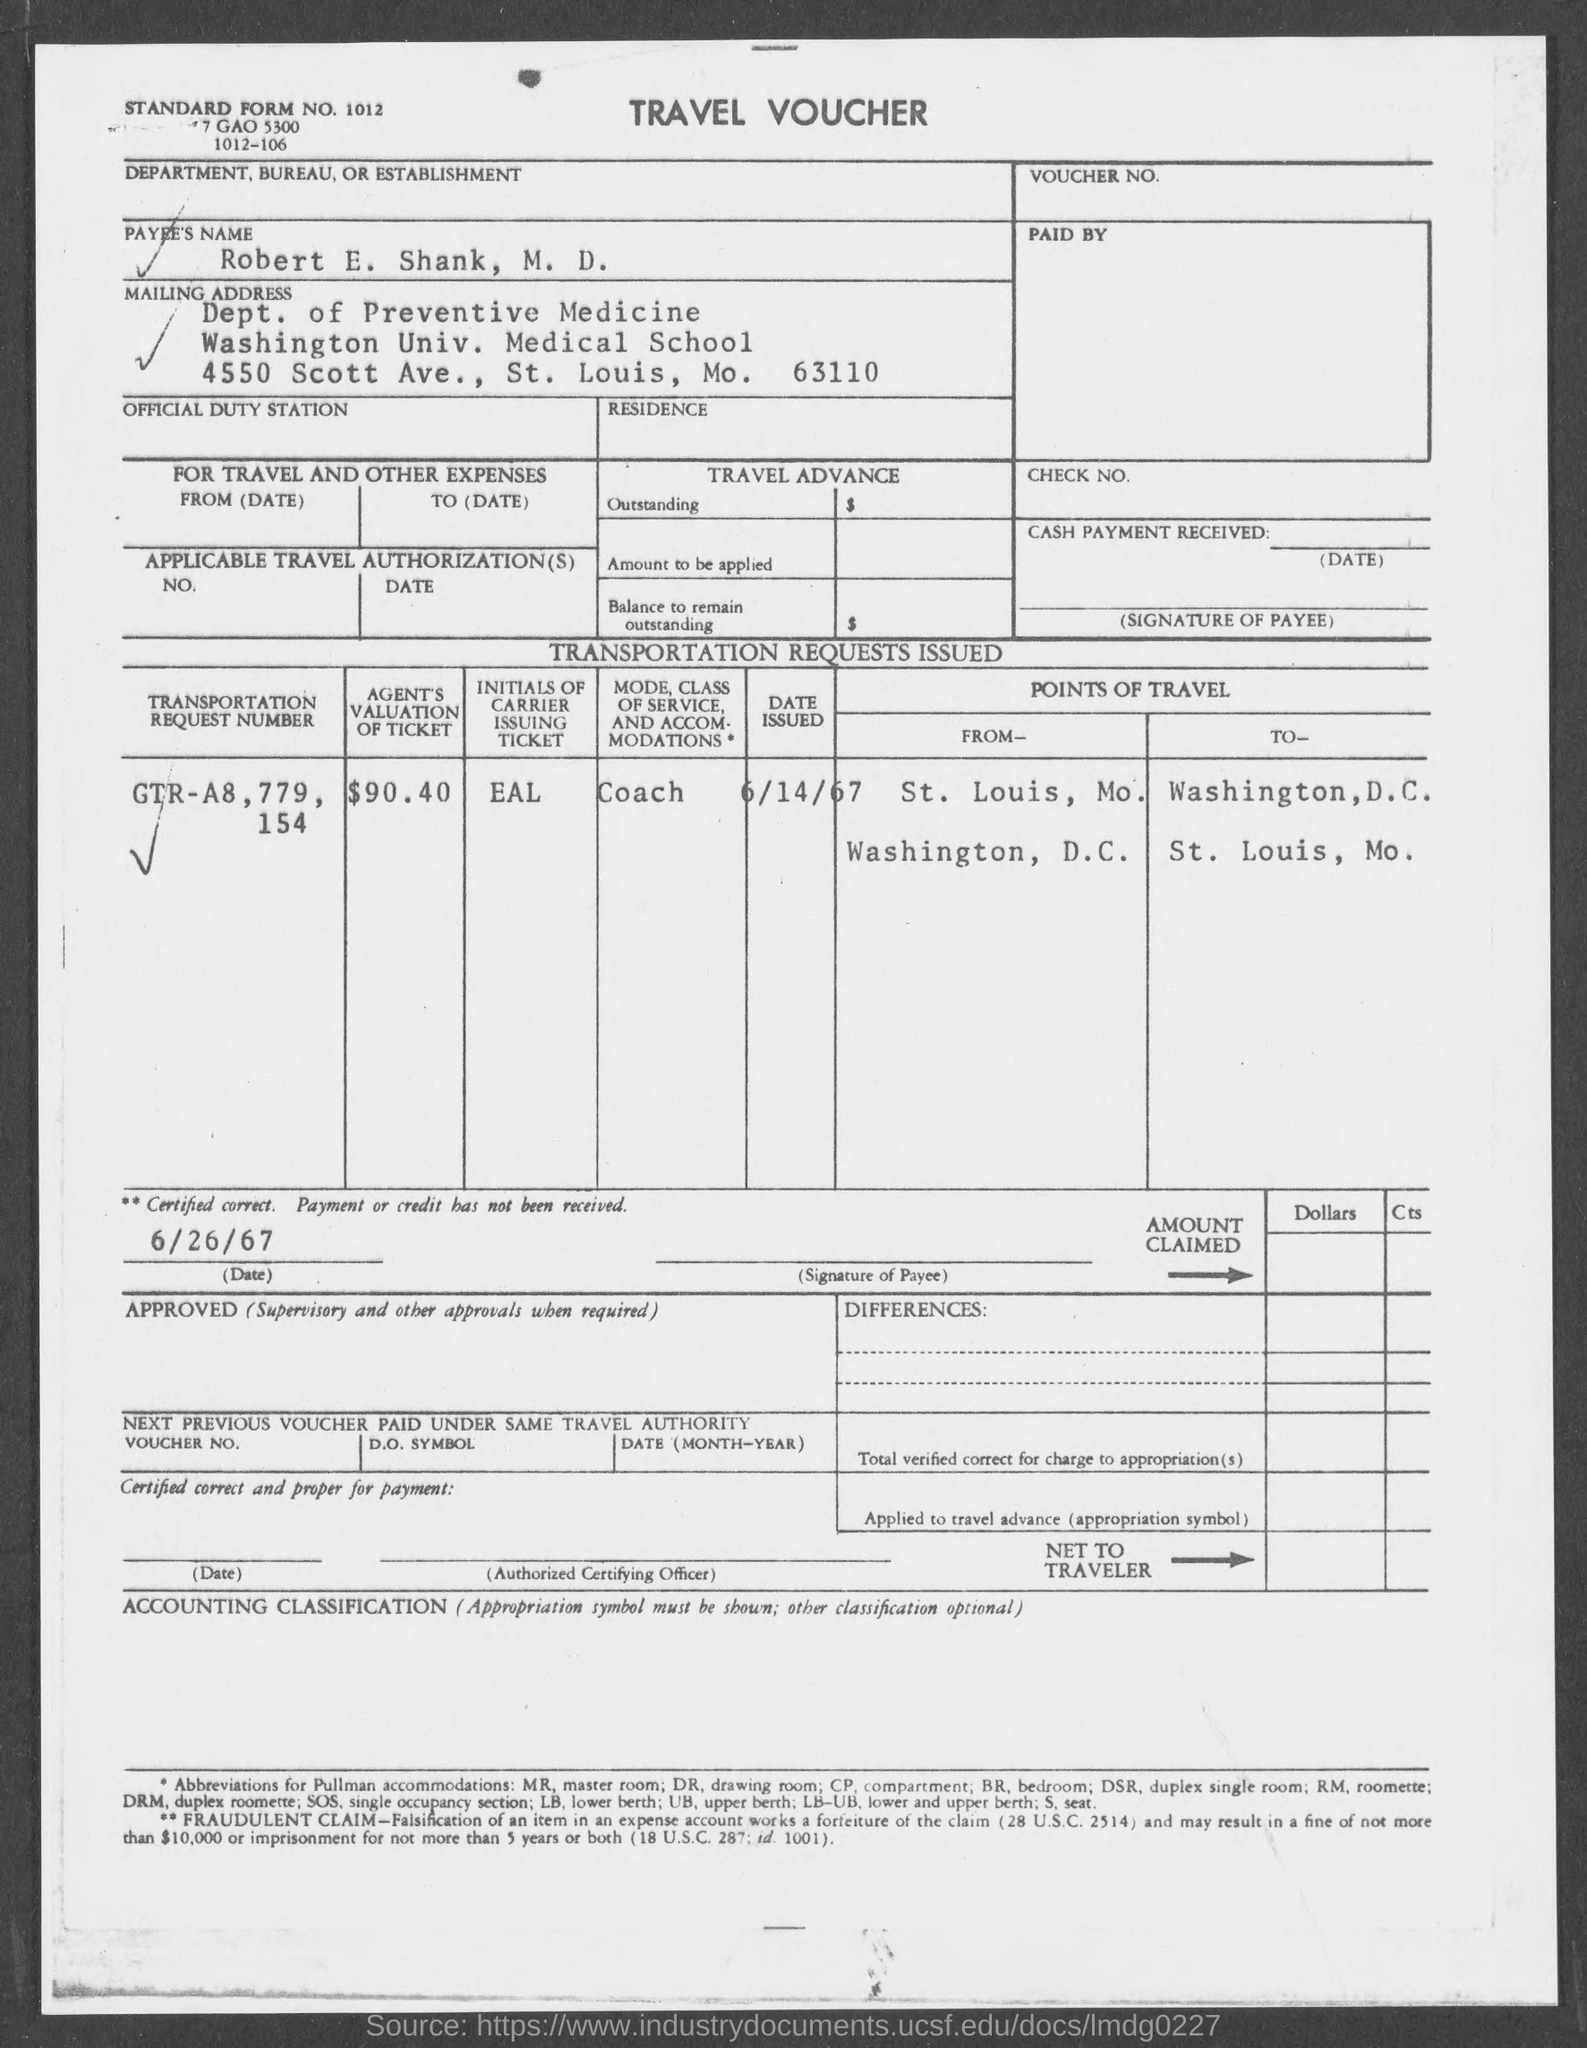What is the payee's name ?
Your answer should be very brief. Robert E. Shank. What is the amount of agents valuation of ticket ?
Ensure brevity in your answer.  90.40. What  is the mode class of service and accommodations ?
Offer a very short reply. Coach. 